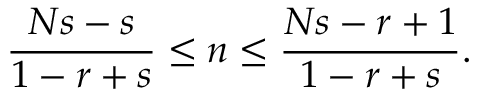<formula> <loc_0><loc_0><loc_500><loc_500>\frac { N s - s } { 1 - r + s } \leq n \leq \frac { N s - r + 1 } { 1 - r + s } .</formula> 